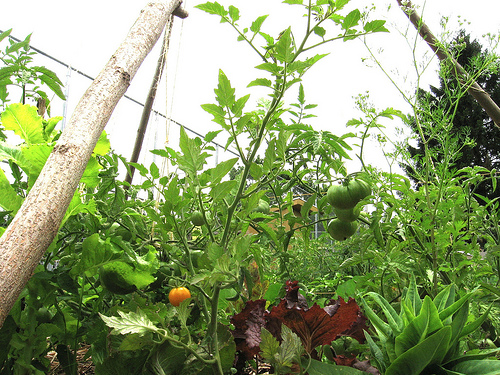<image>
Is the sky behind the plant? Yes. From this viewpoint, the sky is positioned behind the plant, with the plant partially or fully occluding the sky. 